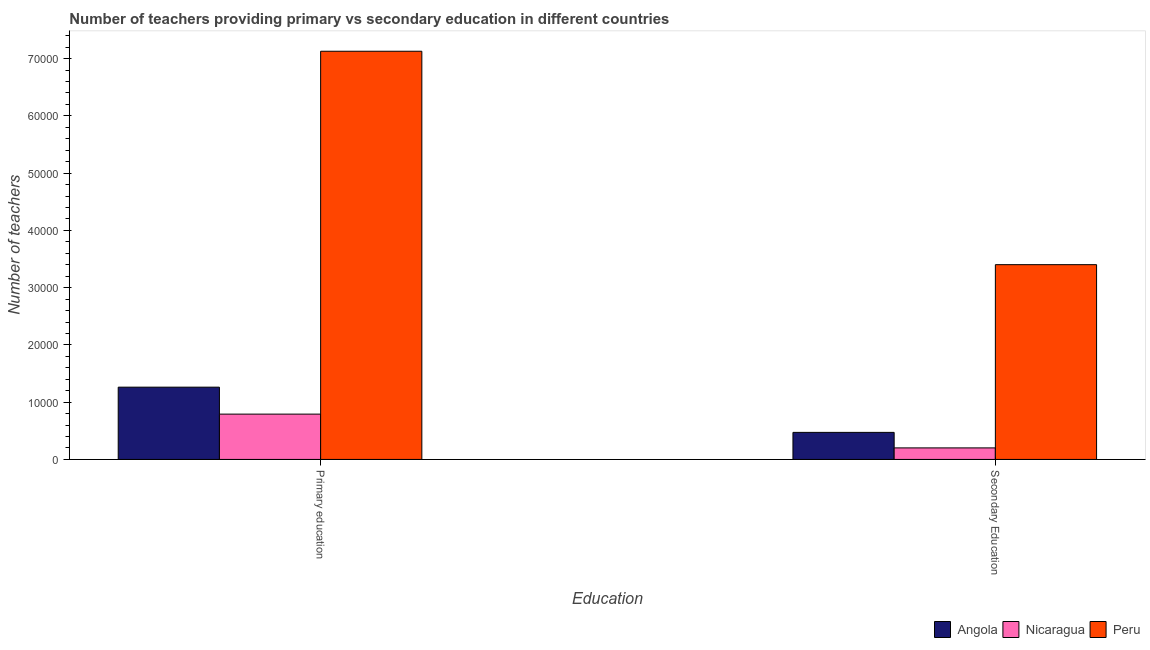How many different coloured bars are there?
Your answer should be compact. 3. Are the number of bars on each tick of the X-axis equal?
Provide a succinct answer. Yes. How many bars are there on the 2nd tick from the left?
Your response must be concise. 3. How many bars are there on the 2nd tick from the right?
Give a very brief answer. 3. What is the label of the 1st group of bars from the left?
Give a very brief answer. Primary education. What is the number of primary teachers in Angola?
Ensure brevity in your answer.  1.26e+04. Across all countries, what is the maximum number of secondary teachers?
Make the answer very short. 3.40e+04. Across all countries, what is the minimum number of primary teachers?
Your response must be concise. 7914. In which country was the number of secondary teachers maximum?
Offer a very short reply. Peru. In which country was the number of secondary teachers minimum?
Offer a terse response. Nicaragua. What is the total number of secondary teachers in the graph?
Offer a very short reply. 4.08e+04. What is the difference between the number of secondary teachers in Angola and that in Nicaragua?
Ensure brevity in your answer.  2709. What is the difference between the number of secondary teachers in Nicaragua and the number of primary teachers in Angola?
Give a very brief answer. -1.06e+04. What is the average number of secondary teachers per country?
Ensure brevity in your answer.  1.36e+04. What is the difference between the number of primary teachers and number of secondary teachers in Angola?
Provide a succinct answer. 7899. What is the ratio of the number of secondary teachers in Nicaragua to that in Peru?
Your response must be concise. 0.06. Is the number of primary teachers in Nicaragua less than that in Angola?
Offer a very short reply. Yes. What does the 3rd bar from the right in Secondary Education represents?
Give a very brief answer. Angola. How many bars are there?
Your answer should be very brief. 6. Are all the bars in the graph horizontal?
Offer a very short reply. No. How many countries are there in the graph?
Ensure brevity in your answer.  3. Does the graph contain grids?
Provide a short and direct response. No. How many legend labels are there?
Make the answer very short. 3. What is the title of the graph?
Your answer should be very brief. Number of teachers providing primary vs secondary education in different countries. What is the label or title of the X-axis?
Your response must be concise. Education. What is the label or title of the Y-axis?
Keep it short and to the point. Number of teachers. What is the Number of teachers in Angola in Primary education?
Keep it short and to the point. 1.26e+04. What is the Number of teachers of Nicaragua in Primary education?
Offer a terse response. 7914. What is the Number of teachers of Peru in Primary education?
Give a very brief answer. 7.13e+04. What is the Number of teachers in Angola in Secondary Education?
Ensure brevity in your answer.  4723. What is the Number of teachers of Nicaragua in Secondary Education?
Ensure brevity in your answer.  2014. What is the Number of teachers of Peru in Secondary Education?
Make the answer very short. 3.40e+04. Across all Education, what is the maximum Number of teachers in Angola?
Your answer should be very brief. 1.26e+04. Across all Education, what is the maximum Number of teachers in Nicaragua?
Your answer should be very brief. 7914. Across all Education, what is the maximum Number of teachers of Peru?
Your answer should be very brief. 7.13e+04. Across all Education, what is the minimum Number of teachers in Angola?
Make the answer very short. 4723. Across all Education, what is the minimum Number of teachers in Nicaragua?
Give a very brief answer. 2014. Across all Education, what is the minimum Number of teachers of Peru?
Keep it short and to the point. 3.40e+04. What is the total Number of teachers in Angola in the graph?
Give a very brief answer. 1.73e+04. What is the total Number of teachers in Nicaragua in the graph?
Offer a very short reply. 9928. What is the total Number of teachers in Peru in the graph?
Give a very brief answer. 1.05e+05. What is the difference between the Number of teachers in Angola in Primary education and that in Secondary Education?
Offer a terse response. 7899. What is the difference between the Number of teachers of Nicaragua in Primary education and that in Secondary Education?
Keep it short and to the point. 5900. What is the difference between the Number of teachers in Peru in Primary education and that in Secondary Education?
Keep it short and to the point. 3.73e+04. What is the difference between the Number of teachers of Angola in Primary education and the Number of teachers of Nicaragua in Secondary Education?
Your answer should be very brief. 1.06e+04. What is the difference between the Number of teachers in Angola in Primary education and the Number of teachers in Peru in Secondary Education?
Your response must be concise. -2.14e+04. What is the difference between the Number of teachers in Nicaragua in Primary education and the Number of teachers in Peru in Secondary Education?
Provide a succinct answer. -2.61e+04. What is the average Number of teachers of Angola per Education?
Ensure brevity in your answer.  8672.5. What is the average Number of teachers of Nicaragua per Education?
Provide a succinct answer. 4964. What is the average Number of teachers of Peru per Education?
Give a very brief answer. 5.27e+04. What is the difference between the Number of teachers in Angola and Number of teachers in Nicaragua in Primary education?
Ensure brevity in your answer.  4708. What is the difference between the Number of teachers of Angola and Number of teachers of Peru in Primary education?
Offer a terse response. -5.87e+04. What is the difference between the Number of teachers of Nicaragua and Number of teachers of Peru in Primary education?
Offer a terse response. -6.34e+04. What is the difference between the Number of teachers of Angola and Number of teachers of Nicaragua in Secondary Education?
Offer a very short reply. 2709. What is the difference between the Number of teachers in Angola and Number of teachers in Peru in Secondary Education?
Your response must be concise. -2.93e+04. What is the difference between the Number of teachers of Nicaragua and Number of teachers of Peru in Secondary Education?
Your answer should be very brief. -3.20e+04. What is the ratio of the Number of teachers in Angola in Primary education to that in Secondary Education?
Keep it short and to the point. 2.67. What is the ratio of the Number of teachers of Nicaragua in Primary education to that in Secondary Education?
Your answer should be compact. 3.93. What is the ratio of the Number of teachers of Peru in Primary education to that in Secondary Education?
Ensure brevity in your answer.  2.1. What is the difference between the highest and the second highest Number of teachers of Angola?
Your answer should be very brief. 7899. What is the difference between the highest and the second highest Number of teachers in Nicaragua?
Provide a succinct answer. 5900. What is the difference between the highest and the second highest Number of teachers of Peru?
Offer a terse response. 3.73e+04. What is the difference between the highest and the lowest Number of teachers in Angola?
Give a very brief answer. 7899. What is the difference between the highest and the lowest Number of teachers in Nicaragua?
Provide a succinct answer. 5900. What is the difference between the highest and the lowest Number of teachers in Peru?
Offer a terse response. 3.73e+04. 